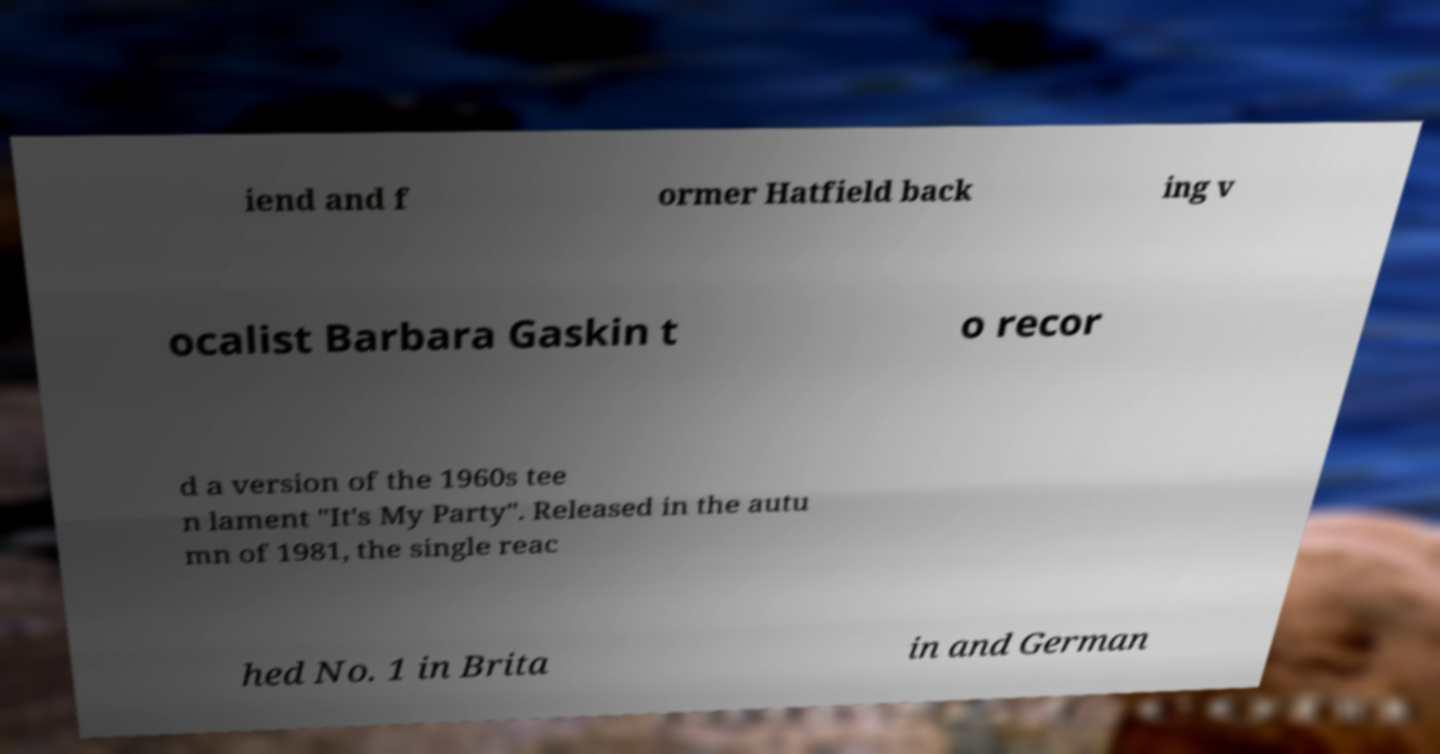I need the written content from this picture converted into text. Can you do that? iend and f ormer Hatfield back ing v ocalist Barbara Gaskin t o recor d a version of the 1960s tee n lament "It's My Party". Released in the autu mn of 1981, the single reac hed No. 1 in Brita in and German 